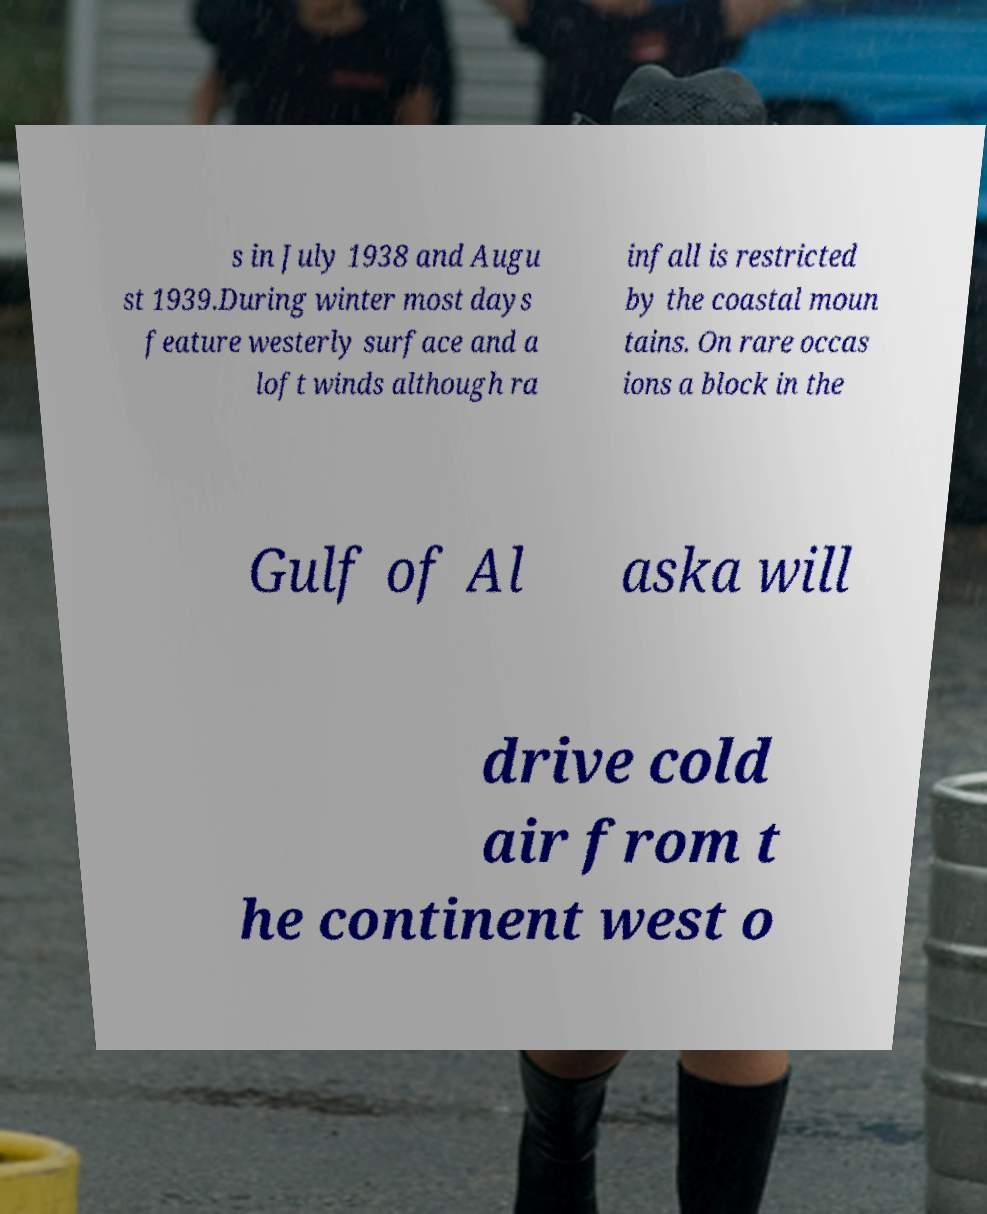There's text embedded in this image that I need extracted. Can you transcribe it verbatim? s in July 1938 and Augu st 1939.During winter most days feature westerly surface and a loft winds although ra infall is restricted by the coastal moun tains. On rare occas ions a block in the Gulf of Al aska will drive cold air from t he continent west o 